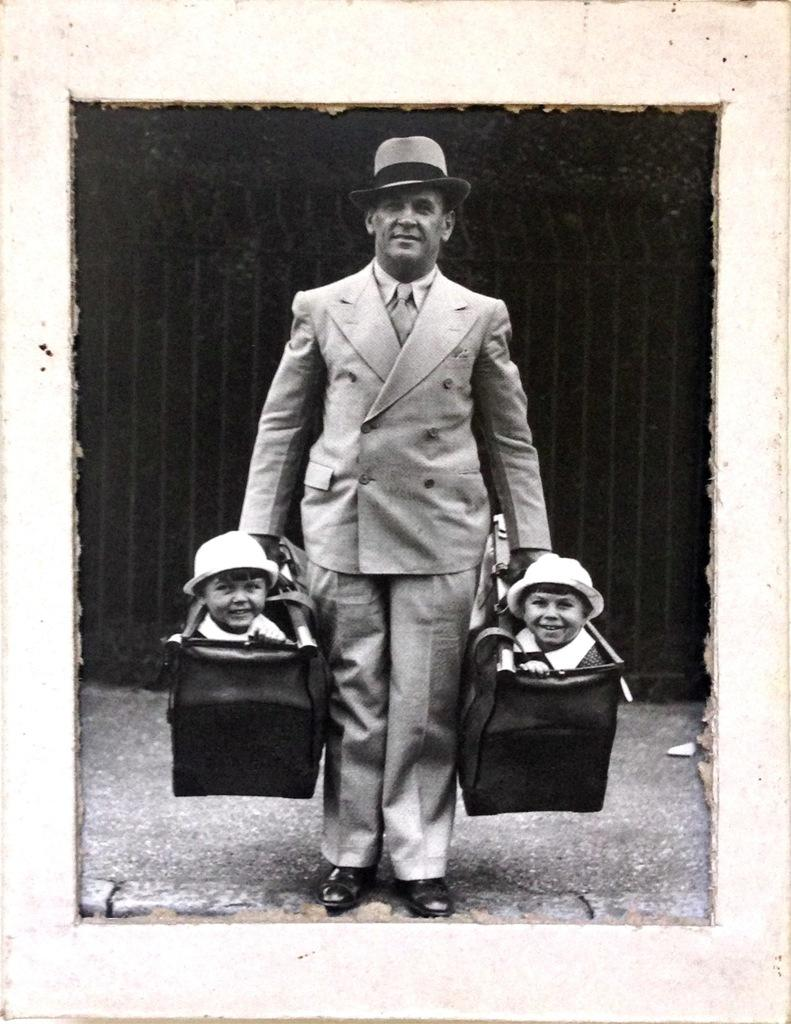What type of picture is in the image? The image contains a black and white picture. What is happening in the picture? The picture depicts a man carrying bags. What is inside the bags? The bags contain children. Where is the man standing? The man is standing on the floor. What can be seen in the background of the image? There is a fence in the background of the image. What type of jeans is the man wearing in the image? The image is in black and white, so it is not possible to determine the color or type of jeans the man might be wearing. Additionally, the man's clothing is not mentioned in the provided facts. 